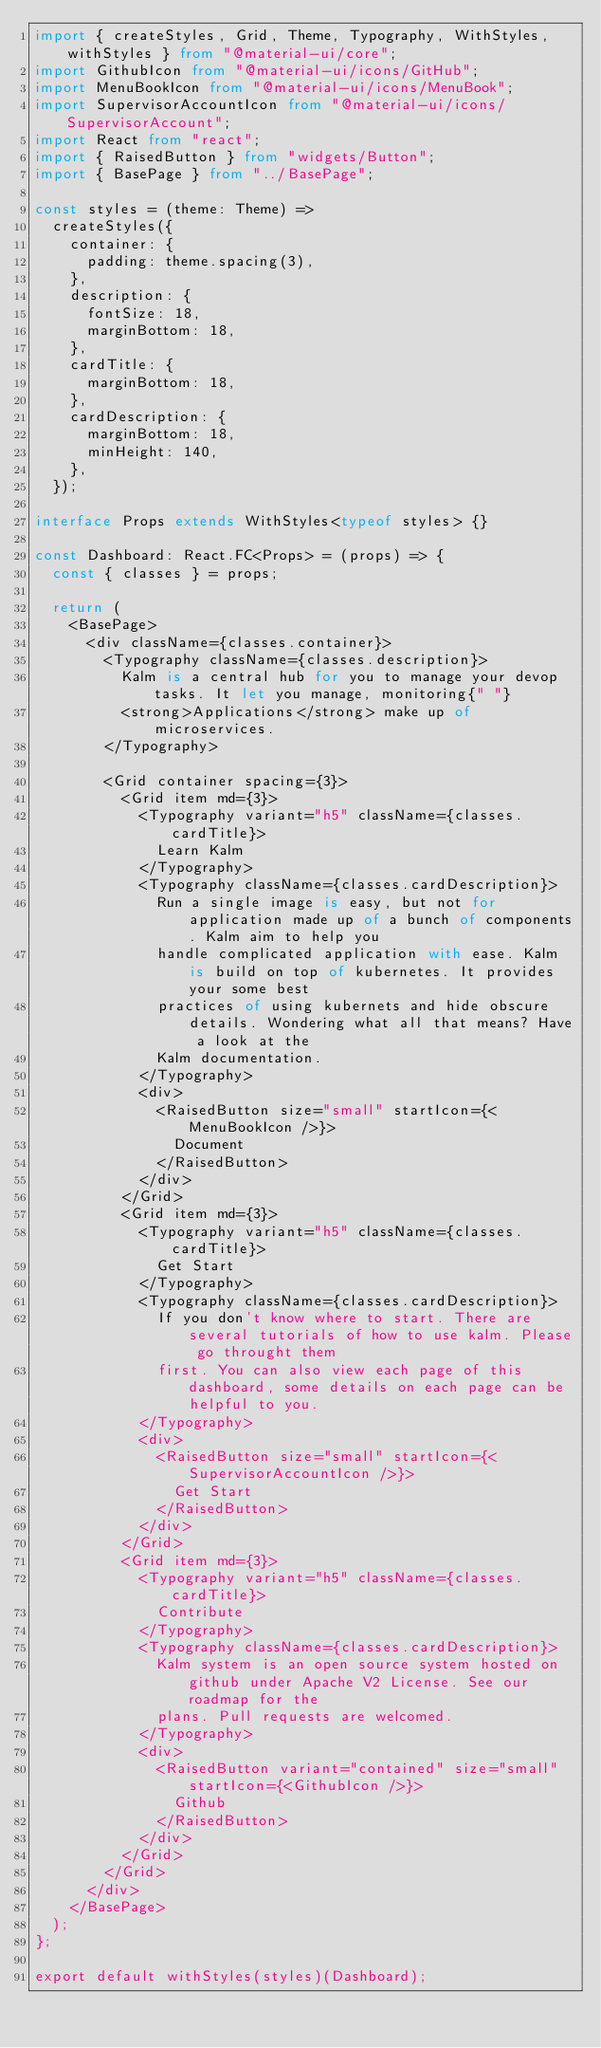<code> <loc_0><loc_0><loc_500><loc_500><_TypeScript_>import { createStyles, Grid, Theme, Typography, WithStyles, withStyles } from "@material-ui/core";
import GithubIcon from "@material-ui/icons/GitHub";
import MenuBookIcon from "@material-ui/icons/MenuBook";
import SupervisorAccountIcon from "@material-ui/icons/SupervisorAccount";
import React from "react";
import { RaisedButton } from "widgets/Button";
import { BasePage } from "../BasePage";

const styles = (theme: Theme) =>
  createStyles({
    container: {
      padding: theme.spacing(3),
    },
    description: {
      fontSize: 18,
      marginBottom: 18,
    },
    cardTitle: {
      marginBottom: 18,
    },
    cardDescription: {
      marginBottom: 18,
      minHeight: 140,
    },
  });

interface Props extends WithStyles<typeof styles> {}

const Dashboard: React.FC<Props> = (props) => {
  const { classes } = props;

  return (
    <BasePage>
      <div className={classes.container}>
        <Typography className={classes.description}>
          Kalm is a central hub for you to manage your devop tasks. It let you manage, monitoring{" "}
          <strong>Applications</strong> make up of microservices.
        </Typography>

        <Grid container spacing={3}>
          <Grid item md={3}>
            <Typography variant="h5" className={classes.cardTitle}>
              Learn Kalm
            </Typography>
            <Typography className={classes.cardDescription}>
              Run a single image is easy, but not for application made up of a bunch of components. Kalm aim to help you
              handle complicated application with ease. Kalm is build on top of kubernetes. It provides your some best
              practices of using kubernets and hide obscure details. Wondering what all that means? Have a look at the
              Kalm documentation.
            </Typography>
            <div>
              <RaisedButton size="small" startIcon={<MenuBookIcon />}>
                Document
              </RaisedButton>
            </div>
          </Grid>
          <Grid item md={3}>
            <Typography variant="h5" className={classes.cardTitle}>
              Get Start
            </Typography>
            <Typography className={classes.cardDescription}>
              If you don't know where to start. There are several tutorials of how to use kalm. Please go throught them
              first. You can also view each page of this dashboard, some details on each page can be helpful to you.
            </Typography>
            <div>
              <RaisedButton size="small" startIcon={<SupervisorAccountIcon />}>
                Get Start
              </RaisedButton>
            </div>
          </Grid>
          <Grid item md={3}>
            <Typography variant="h5" className={classes.cardTitle}>
              Contribute
            </Typography>
            <Typography className={classes.cardDescription}>
              Kalm system is an open source system hosted on github under Apache V2 License. See our roadmap for the
              plans. Pull requests are welcomed.
            </Typography>
            <div>
              <RaisedButton variant="contained" size="small" startIcon={<GithubIcon />}>
                Github
              </RaisedButton>
            </div>
          </Grid>
        </Grid>
      </div>
    </BasePage>
  );
};

export default withStyles(styles)(Dashboard);
</code> 